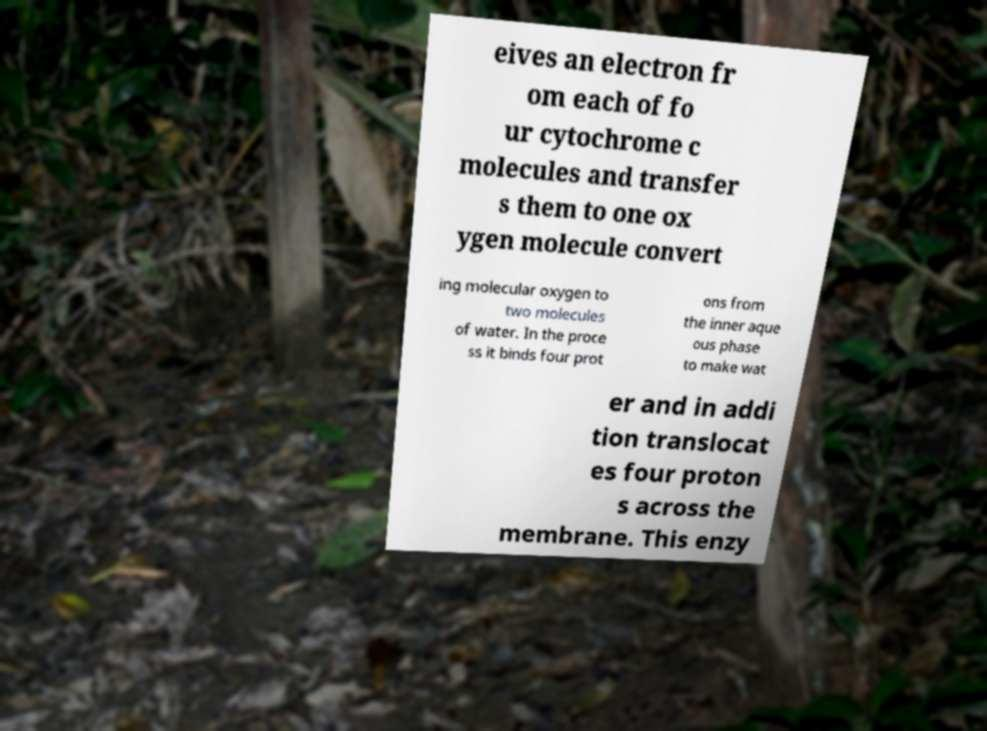Can you accurately transcribe the text from the provided image for me? eives an electron fr om each of fo ur cytochrome c molecules and transfer s them to one ox ygen molecule convert ing molecular oxygen to two molecules of water. In the proce ss it binds four prot ons from the inner aque ous phase to make wat er and in addi tion translocat es four proton s across the membrane. This enzy 